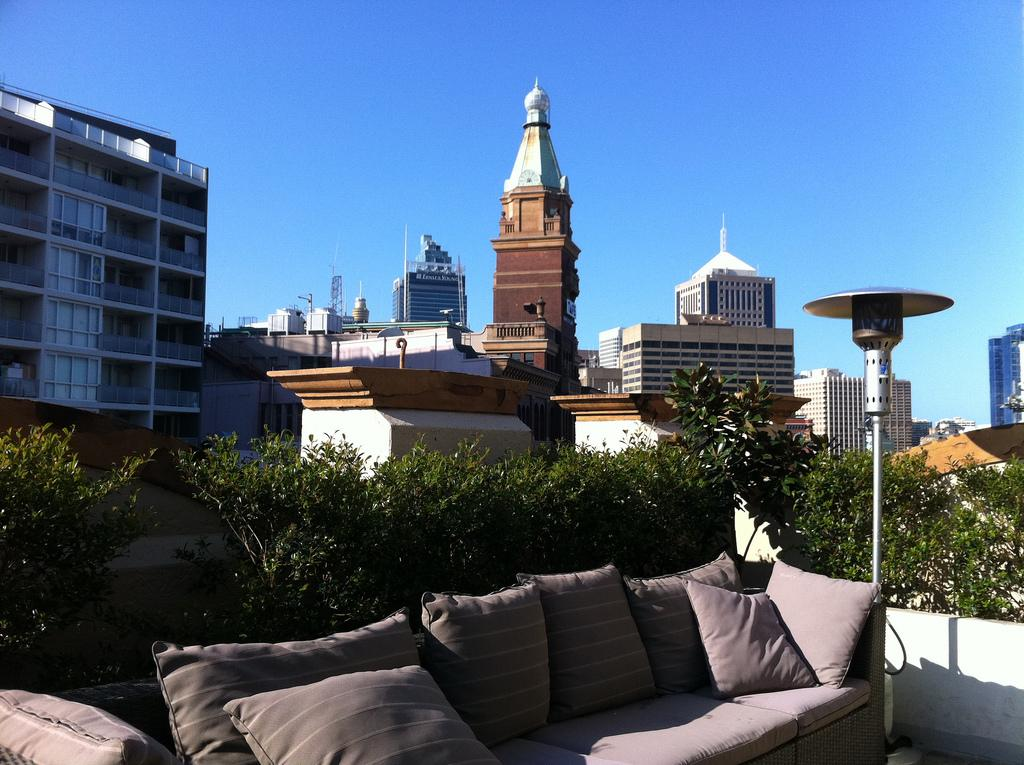What type of furniture is present in the image? There is a sofa in the image. What material is the metal rod made of? The metal rod in the image is made of metal. What type of natural elements can be seen in the image? There are trees in the image. What type of man-made structures are visible in the image? There are buildings in the image. Can you hear the acoustics of the pump in the image? There is no pump present in the image, so it is not possible to hear its acoustics. Is the sofa sinking into the quicksand in the image? There is no quicksand present in the image, and the sofa is not sinking. 